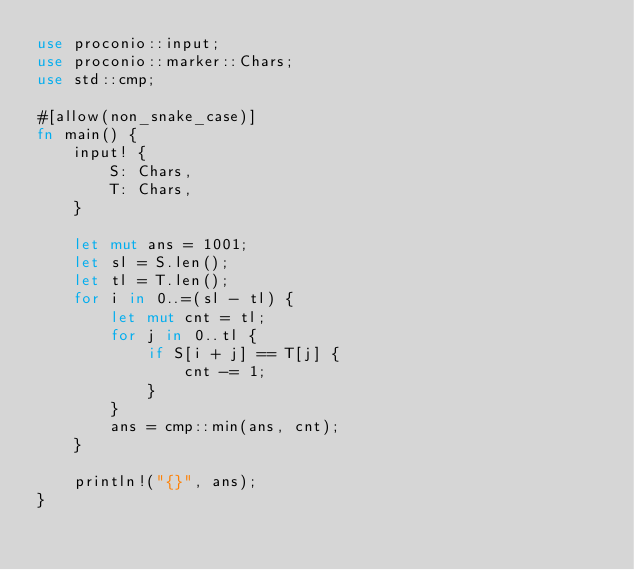<code> <loc_0><loc_0><loc_500><loc_500><_Rust_>use proconio::input;
use proconio::marker::Chars;
use std::cmp;

#[allow(non_snake_case)]
fn main() {
    input! {
        S: Chars,
        T: Chars,
    }

    let mut ans = 1001;
    let sl = S.len();
    let tl = T.len();
    for i in 0..=(sl - tl) {
        let mut cnt = tl;
        for j in 0..tl {
            if S[i + j] == T[j] {
                cnt -= 1;
            }
        }
        ans = cmp::min(ans, cnt);
    }

    println!("{}", ans);
}
</code> 